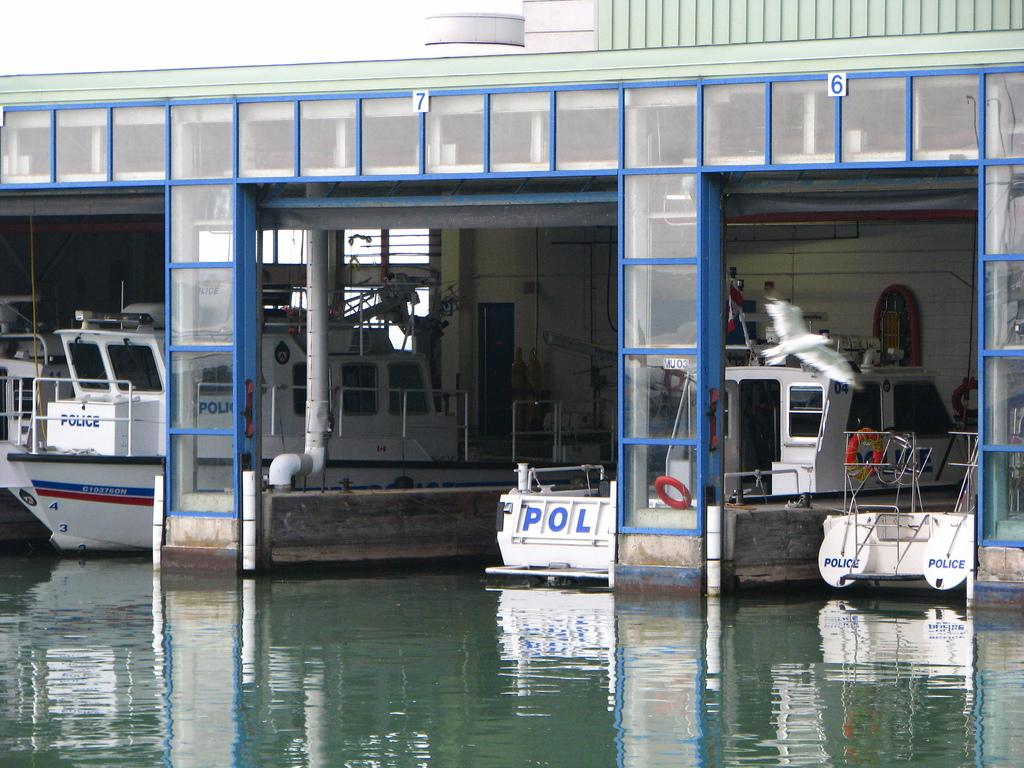What can be seen in the image that is used for transportation on water? There are boats in the image that are used for transportation on water. What type of animal is present on the right side of the image? There is a bird on the right side of the image. What is the color of the bird in the image? The bird in the image is white in color. What is visible at the bottom of the image? There is water visible at the bottom of the image. What type of butter is being used to work on the bird's skin in the image? There is no butter or work being done on the bird's skin in the image; it simply shows a white bird on the right side of the image. 